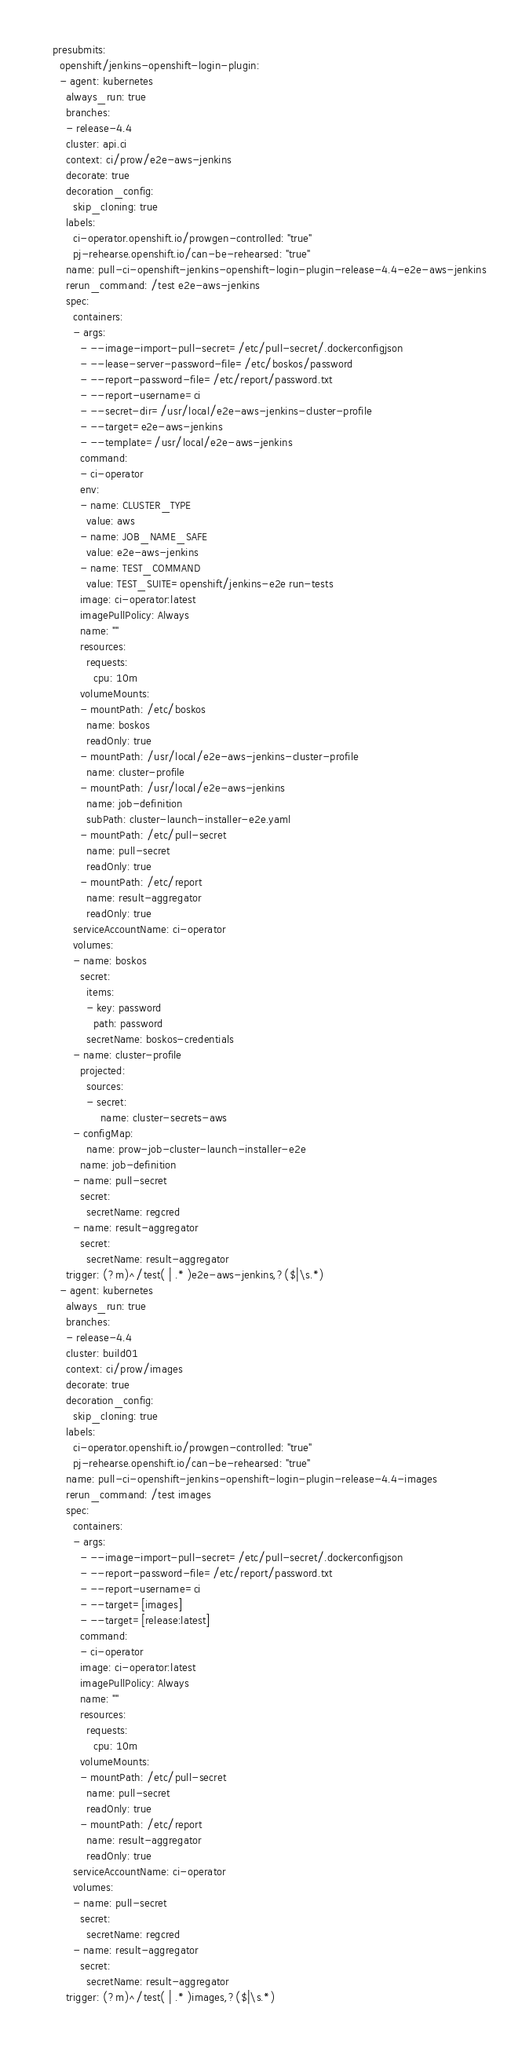<code> <loc_0><loc_0><loc_500><loc_500><_YAML_>presubmits:
  openshift/jenkins-openshift-login-plugin:
  - agent: kubernetes
    always_run: true
    branches:
    - release-4.4
    cluster: api.ci
    context: ci/prow/e2e-aws-jenkins
    decorate: true
    decoration_config:
      skip_cloning: true
    labels:
      ci-operator.openshift.io/prowgen-controlled: "true"
      pj-rehearse.openshift.io/can-be-rehearsed: "true"
    name: pull-ci-openshift-jenkins-openshift-login-plugin-release-4.4-e2e-aws-jenkins
    rerun_command: /test e2e-aws-jenkins
    spec:
      containers:
      - args:
        - --image-import-pull-secret=/etc/pull-secret/.dockerconfigjson
        - --lease-server-password-file=/etc/boskos/password
        - --report-password-file=/etc/report/password.txt
        - --report-username=ci
        - --secret-dir=/usr/local/e2e-aws-jenkins-cluster-profile
        - --target=e2e-aws-jenkins
        - --template=/usr/local/e2e-aws-jenkins
        command:
        - ci-operator
        env:
        - name: CLUSTER_TYPE
          value: aws
        - name: JOB_NAME_SAFE
          value: e2e-aws-jenkins
        - name: TEST_COMMAND
          value: TEST_SUITE=openshift/jenkins-e2e run-tests
        image: ci-operator:latest
        imagePullPolicy: Always
        name: ""
        resources:
          requests:
            cpu: 10m
        volumeMounts:
        - mountPath: /etc/boskos
          name: boskos
          readOnly: true
        - mountPath: /usr/local/e2e-aws-jenkins-cluster-profile
          name: cluster-profile
        - mountPath: /usr/local/e2e-aws-jenkins
          name: job-definition
          subPath: cluster-launch-installer-e2e.yaml
        - mountPath: /etc/pull-secret
          name: pull-secret
          readOnly: true
        - mountPath: /etc/report
          name: result-aggregator
          readOnly: true
      serviceAccountName: ci-operator
      volumes:
      - name: boskos
        secret:
          items:
          - key: password
            path: password
          secretName: boskos-credentials
      - name: cluster-profile
        projected:
          sources:
          - secret:
              name: cluster-secrets-aws
      - configMap:
          name: prow-job-cluster-launch-installer-e2e
        name: job-definition
      - name: pull-secret
        secret:
          secretName: regcred
      - name: result-aggregator
        secret:
          secretName: result-aggregator
    trigger: (?m)^/test( | .* )e2e-aws-jenkins,?($|\s.*)
  - agent: kubernetes
    always_run: true
    branches:
    - release-4.4
    cluster: build01
    context: ci/prow/images
    decorate: true
    decoration_config:
      skip_cloning: true
    labels:
      ci-operator.openshift.io/prowgen-controlled: "true"
      pj-rehearse.openshift.io/can-be-rehearsed: "true"
    name: pull-ci-openshift-jenkins-openshift-login-plugin-release-4.4-images
    rerun_command: /test images
    spec:
      containers:
      - args:
        - --image-import-pull-secret=/etc/pull-secret/.dockerconfigjson
        - --report-password-file=/etc/report/password.txt
        - --report-username=ci
        - --target=[images]
        - --target=[release:latest]
        command:
        - ci-operator
        image: ci-operator:latest
        imagePullPolicy: Always
        name: ""
        resources:
          requests:
            cpu: 10m
        volumeMounts:
        - mountPath: /etc/pull-secret
          name: pull-secret
          readOnly: true
        - mountPath: /etc/report
          name: result-aggregator
          readOnly: true
      serviceAccountName: ci-operator
      volumes:
      - name: pull-secret
        secret:
          secretName: regcred
      - name: result-aggregator
        secret:
          secretName: result-aggregator
    trigger: (?m)^/test( | .* )images,?($|\s.*)
</code> 